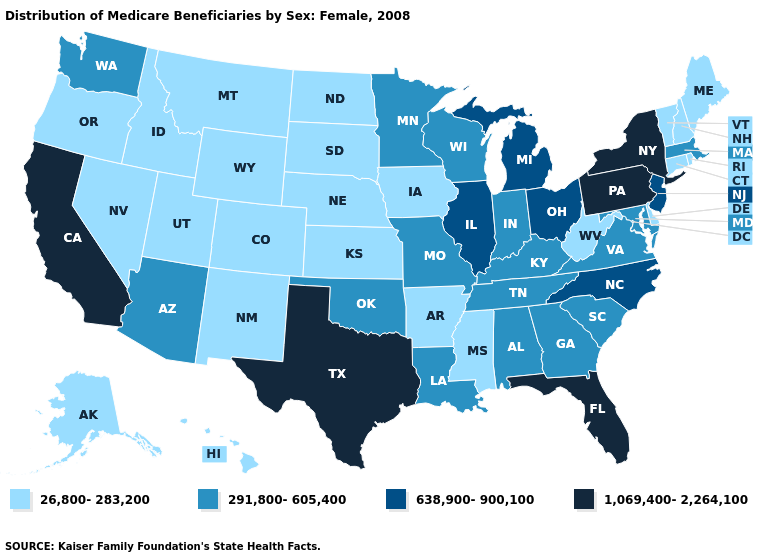What is the value of Alabama?
Answer briefly. 291,800-605,400. What is the value of Montana?
Answer briefly. 26,800-283,200. What is the highest value in the West ?
Be succinct. 1,069,400-2,264,100. Does Kentucky have the highest value in the USA?
Quick response, please. No. What is the value of Nevada?
Quick response, please. 26,800-283,200. Among the states that border Utah , which have the lowest value?
Write a very short answer. Colorado, Idaho, Nevada, New Mexico, Wyoming. What is the lowest value in the USA?
Give a very brief answer. 26,800-283,200. What is the value of Minnesota?
Give a very brief answer. 291,800-605,400. Name the states that have a value in the range 1,069,400-2,264,100?
Give a very brief answer. California, Florida, New York, Pennsylvania, Texas. Which states have the lowest value in the USA?
Quick response, please. Alaska, Arkansas, Colorado, Connecticut, Delaware, Hawaii, Idaho, Iowa, Kansas, Maine, Mississippi, Montana, Nebraska, Nevada, New Hampshire, New Mexico, North Dakota, Oregon, Rhode Island, South Dakota, Utah, Vermont, West Virginia, Wyoming. Does Alabama have the lowest value in the South?
Short answer required. No. Which states have the highest value in the USA?
Quick response, please. California, Florida, New York, Pennsylvania, Texas. What is the value of Oklahoma?
Concise answer only. 291,800-605,400. Name the states that have a value in the range 291,800-605,400?
Concise answer only. Alabama, Arizona, Georgia, Indiana, Kentucky, Louisiana, Maryland, Massachusetts, Minnesota, Missouri, Oklahoma, South Carolina, Tennessee, Virginia, Washington, Wisconsin. What is the highest value in states that border Georgia?
Write a very short answer. 1,069,400-2,264,100. 